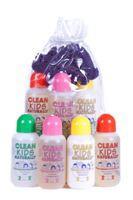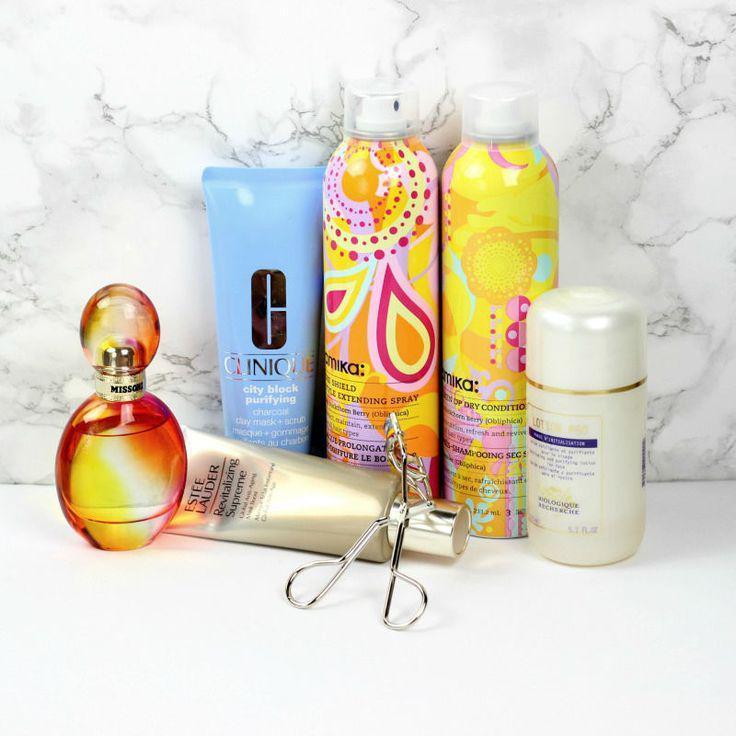The first image is the image on the left, the second image is the image on the right. Assess this claim about the two images: "Three containers are shown in one of the images.". Correct or not? Answer yes or no. No. The first image is the image on the left, the second image is the image on the right. Considering the images on both sides, is "One image shows exactly three skincare products, which are in a row and upright." valid? Answer yes or no. No. 